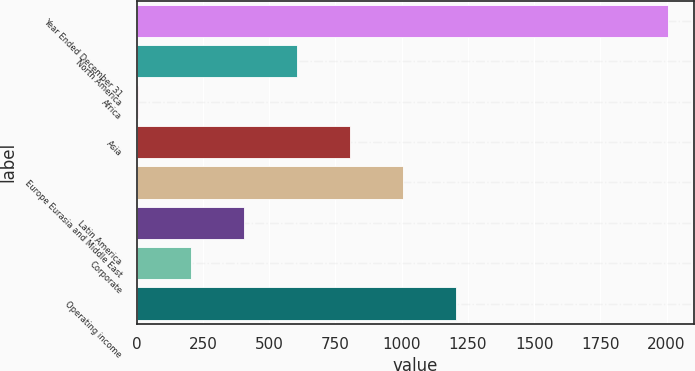<chart> <loc_0><loc_0><loc_500><loc_500><bar_chart><fcel>Year Ended December 31<fcel>North America<fcel>Africa<fcel>Asia<fcel>Europe Eurasia and Middle East<fcel>Latin America<fcel>Corporate<fcel>Operating income<nl><fcel>2004<fcel>605.4<fcel>6<fcel>805.2<fcel>1005<fcel>405.6<fcel>205.8<fcel>1204.8<nl></chart> 